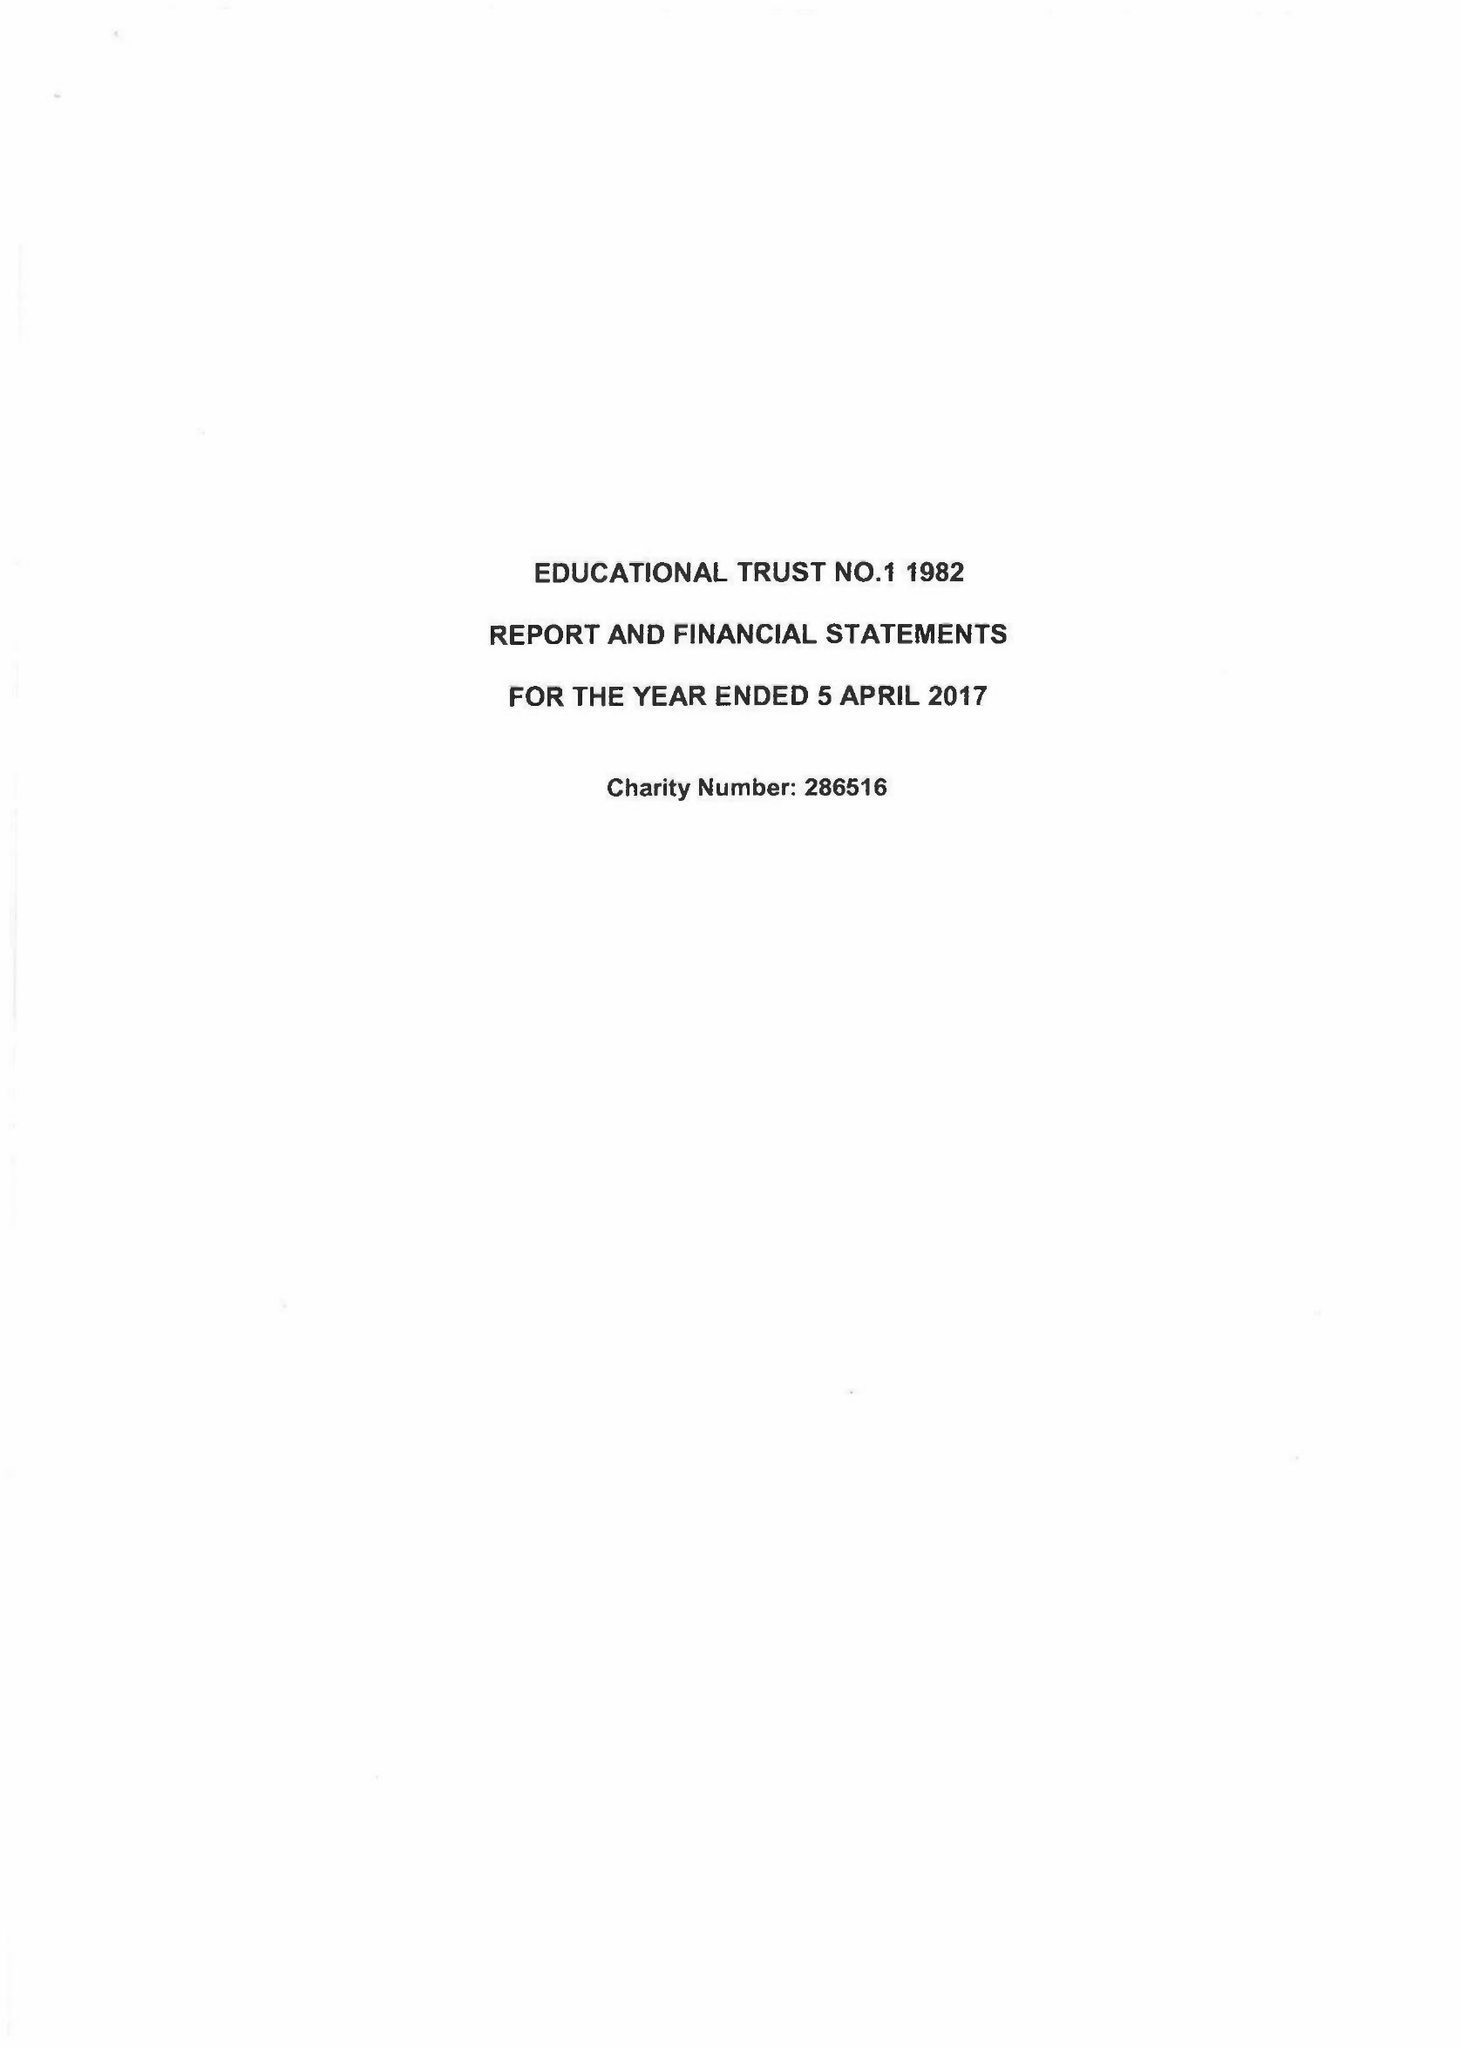What is the value for the spending_annually_in_british_pounds?
Answer the question using a single word or phrase. 132604.00 